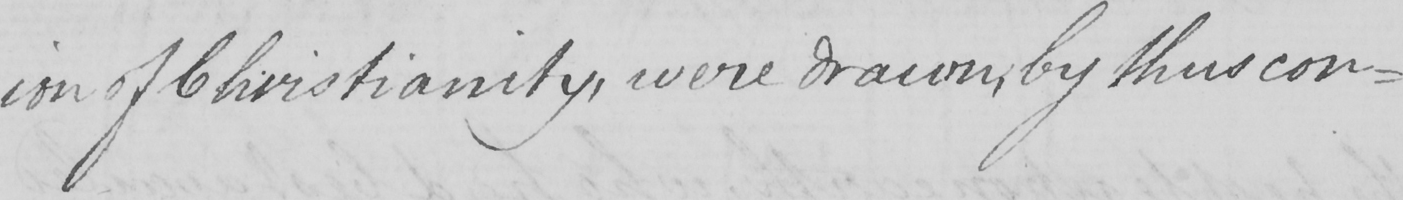Transcribe the text shown in this historical manuscript line. -ion of Christianity , were drawn , by thus con- 